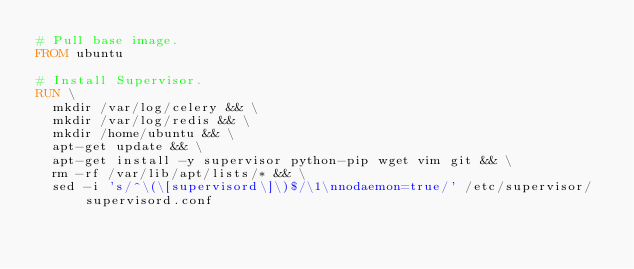<code> <loc_0><loc_0><loc_500><loc_500><_Dockerfile_># Pull base image.
FROM ubuntu

# Install Supervisor.
RUN \
  mkdir /var/log/celery && \
  mkdir /var/log/redis && \
  mkdir /home/ubuntu && \
  apt-get update && \
  apt-get install -y supervisor python-pip wget vim git && \
  rm -rf /var/lib/apt/lists/* && \
  sed -i 's/^\(\[supervisord\]\)$/\1\nnodaemon=true/' /etc/supervisor/supervisord.conf
</code> 